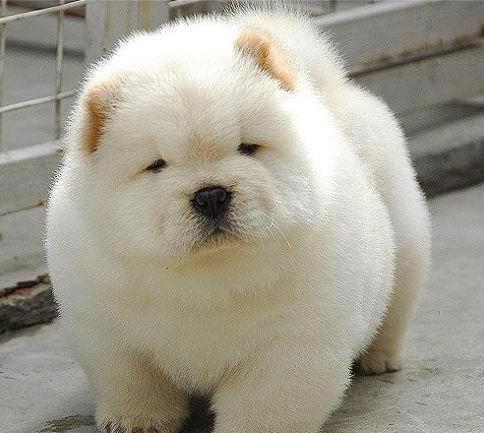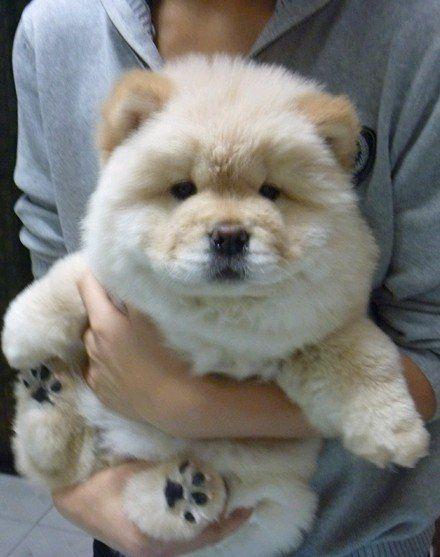The first image is the image on the left, the second image is the image on the right. For the images shown, is this caption "There is at least one cream colored Chow Chow puppy in the image on the left." true? Answer yes or no. Yes. The first image is the image on the left, the second image is the image on the right. Given the left and right images, does the statement "In one image, a woman poses with three dogs" hold true? Answer yes or no. No. 